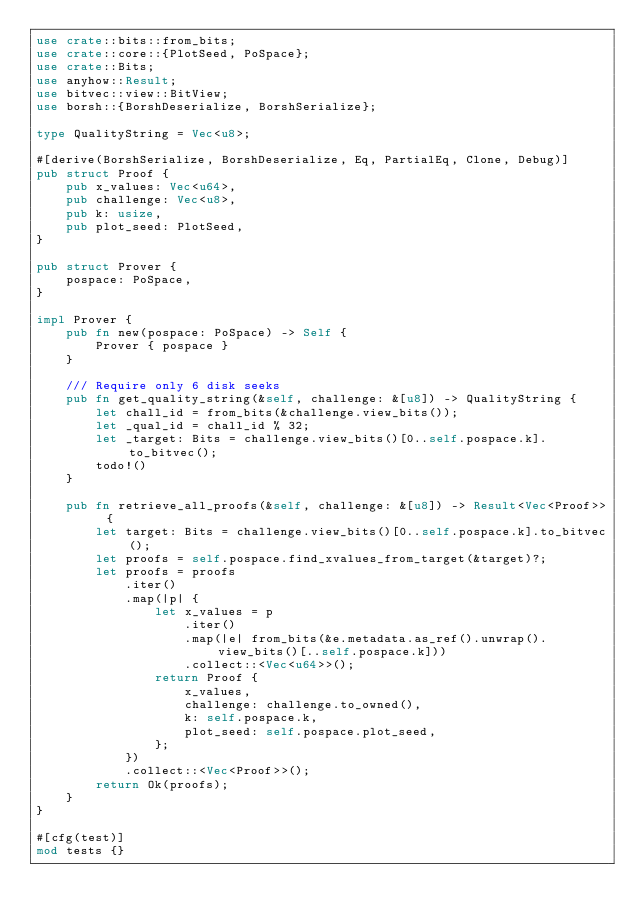<code> <loc_0><loc_0><loc_500><loc_500><_Rust_>use crate::bits::from_bits;
use crate::core::{PlotSeed, PoSpace};
use crate::Bits;
use anyhow::Result;
use bitvec::view::BitView;
use borsh::{BorshDeserialize, BorshSerialize};

type QualityString = Vec<u8>;

#[derive(BorshSerialize, BorshDeserialize, Eq, PartialEq, Clone, Debug)]
pub struct Proof {
    pub x_values: Vec<u64>,
    pub challenge: Vec<u8>,
    pub k: usize,
    pub plot_seed: PlotSeed,
}

pub struct Prover {
    pospace: PoSpace,
}

impl Prover {
    pub fn new(pospace: PoSpace) -> Self {
        Prover { pospace }
    }

    /// Require only 6 disk seeks
    pub fn get_quality_string(&self, challenge: &[u8]) -> QualityString {
        let chall_id = from_bits(&challenge.view_bits());
        let _qual_id = chall_id % 32;
        let _target: Bits = challenge.view_bits()[0..self.pospace.k].to_bitvec();
        todo!()
    }

    pub fn retrieve_all_proofs(&self, challenge: &[u8]) -> Result<Vec<Proof>> {
        let target: Bits = challenge.view_bits()[0..self.pospace.k].to_bitvec();
        let proofs = self.pospace.find_xvalues_from_target(&target)?;
        let proofs = proofs
            .iter()
            .map(|p| {
                let x_values = p
                    .iter()
                    .map(|e| from_bits(&e.metadata.as_ref().unwrap().view_bits()[..self.pospace.k]))
                    .collect::<Vec<u64>>();
                return Proof {
                    x_values,
                    challenge: challenge.to_owned(),
                    k: self.pospace.k,
                    plot_seed: self.pospace.plot_seed,
                };
            })
            .collect::<Vec<Proof>>();
        return Ok(proofs);
    }
}

#[cfg(test)]
mod tests {}
</code> 